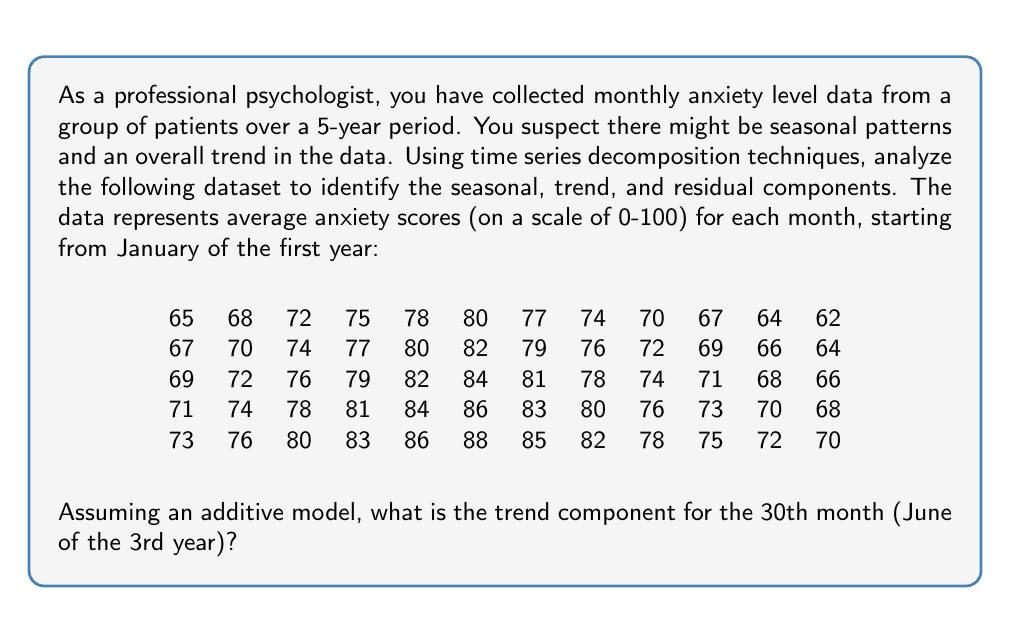Give your solution to this math problem. To decompose the time series data into seasonal, trend, and residual components, we'll follow these steps:

1) First, we need to identify the seasonal pattern. Since we have monthly data, we'll assume a 12-month seasonality.

2) To estimate the trend component, we'll use a centered moving average with a window of 12 months. This will smooth out the seasonal fluctuations.

3) The formula for the centered moving average is:

   $$T_t = \frac{1}{24}(0.5Y_{t-6} + Y_{t-5} + ... + Y_t + ... + Y_{t+5} + 0.5Y_{t+6})$$

   where $T_t$ is the trend component and $Y_t$ is the original data.

4) We'll calculate this for each point, starting from the 7th month and ending 6 months before the end.

5) For the 30th month (index 29 in 0-based indexing), we calculate:

   $$T_{30} = \frac{1}{24}(0.5 \cdot 74 + 76 + 79 + 82 + 84 + 81 + 78 + 74 + 71 + 68 + 66 + 71 + 74 + 0.5 \cdot 78)$$

6) Calculating this value:

   $$T_{30} = \frac{1}{24}(37 + 76 + 79 + 82 + 84 + 81 + 78 + 74 + 71 + 68 + 66 + 71 + 74 + 39)$$
   $$T_{30} = \frac{980}{24} = 40.8333$$

7) Therefore, the trend component for the 30th month is approximately 40.83.

Note: In practice, we would calculate this for all points and then use software to estimate the seasonal and residual components. The seasonal component would be the average deviation from the trend for each month across all years, and the residual would be what's left after subtracting both trend and seasonal components from the original data.
Answer: The trend component for the 30th month (June of the 3rd year) is approximately 40.83. 